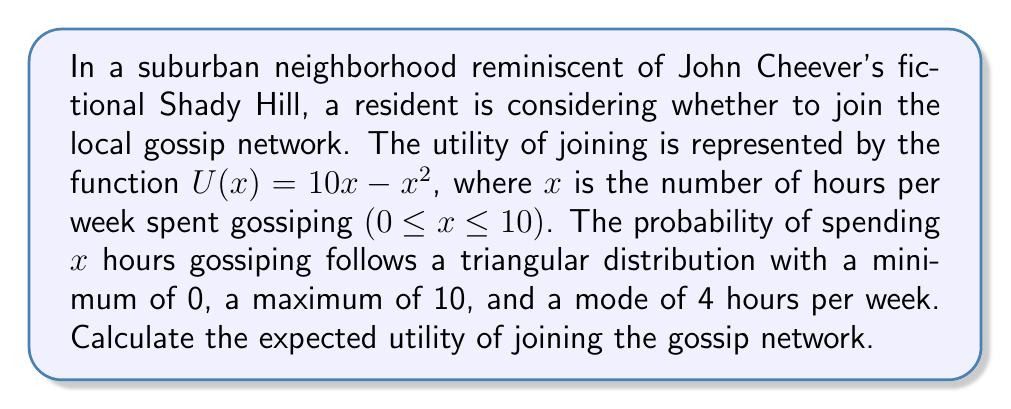Show me your answer to this math problem. To solve this problem, we need to calculate the expected utility using the given utility function and probability distribution. Let's break it down step-by-step:

1) The utility function is given as:
   $U(x) = 10x - x^2$

2) The probability density function (PDF) for a triangular distribution is:
   $$f(x) = \begin{cases}
   \frac{2x}{ab} & \text{for } 0 \leq x \leq 4 \\
   \frac{2(10-x)}{a(b-a)} & \text{for } 4 < x \leq 10
   \end{cases}$$
   where $a = 4$ (mode) and $b = 10$ (maximum)

3) The expected utility is calculated by:
   $$E[U(x)] = \int_0^{10} U(x)f(x)dx$$

4) Let's split this integral into two parts:
   $$E[U(x)] = \int_0^4 (10x - x^2)\frac{2x}{40}dx + \int_4^{10} (10x - x^2)\frac{2(10-x)}{24}dx$$

5) Solving the first integral:
   $$\int_0^4 (10x - x^2)\frac{x}{20}dx = \frac{1}{20}\int_0^4 (10x^2 - x^3)dx = \frac{1}{20}[\frac{10x^3}{3} - \frac{x^4}{4}]_0^4 = \frac{256}{15}$$

6) Solving the second integral:
   $$\int_4^{10} (10x - x^2)\frac{10-x}{12}dx = \frac{1}{12}\int_4^{10} (100x - 20x^2 + x^3)dx = \frac{1}{12}[50x^2 - \frac{20x^3}{3} + \frac{x^4}{4}]_4^{10} = \frac{448}{9}$$

7) The total expected utility is the sum of these two integrals:
   $$E[U(x)] = \frac{256}{15} + \frac{448}{9} = 17.0667 + 49.7778 = 66.8445$$
Answer: The expected utility of joining the gossip network is approximately 66.84. 